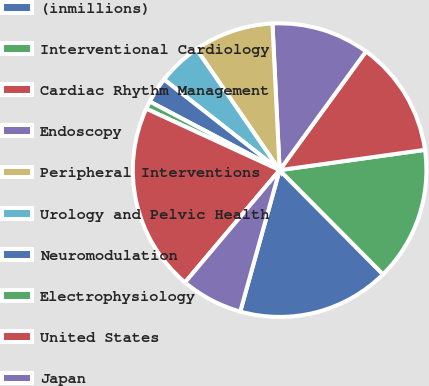Convert chart. <chart><loc_0><loc_0><loc_500><loc_500><pie_chart><fcel>(inmillions)<fcel>Interventional Cardiology<fcel>Cardiac Rhythm Management<fcel>Endoscopy<fcel>Peripheral Interventions<fcel>Urology and Pelvic Health<fcel>Neuromodulation<fcel>Electrophysiology<fcel>United States<fcel>Japan<nl><fcel>16.76%<fcel>14.77%<fcel>12.78%<fcel>10.79%<fcel>8.81%<fcel>4.83%<fcel>2.85%<fcel>0.86%<fcel>20.73%<fcel>6.82%<nl></chart> 